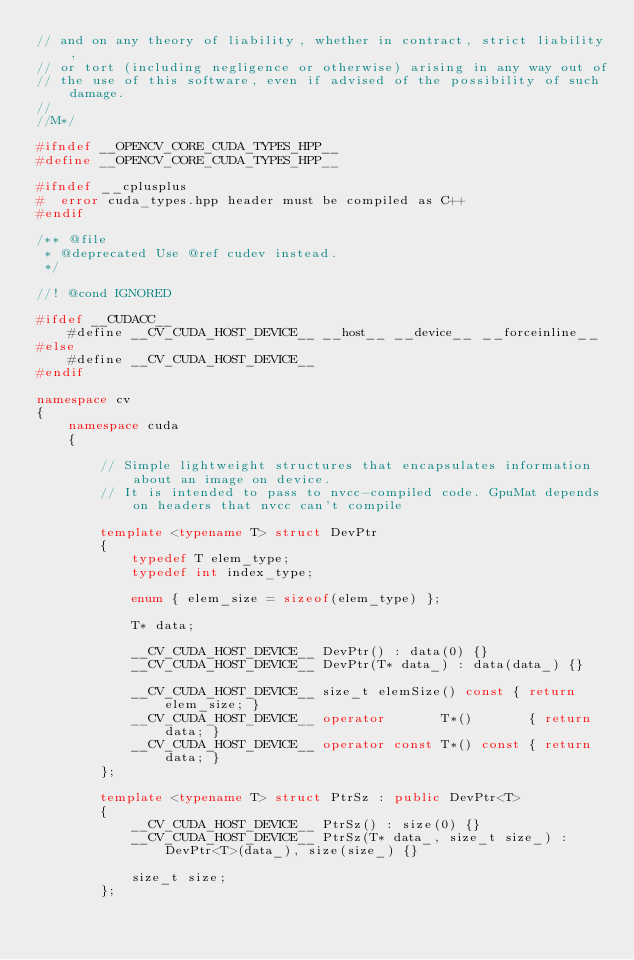Convert code to text. <code><loc_0><loc_0><loc_500><loc_500><_C++_>// and on any theory of liability, whether in contract, strict liability,
// or tort (including negligence or otherwise) arising in any way out of
// the use of this software, even if advised of the possibility of such damage.
//
//M*/

#ifndef __OPENCV_CORE_CUDA_TYPES_HPP__
#define __OPENCV_CORE_CUDA_TYPES_HPP__

#ifndef __cplusplus
#  error cuda_types.hpp header must be compiled as C++
#endif

/** @file
 * @deprecated Use @ref cudev instead.
 */

//! @cond IGNORED

#ifdef __CUDACC__
    #define __CV_CUDA_HOST_DEVICE__ __host__ __device__ __forceinline__
#else
    #define __CV_CUDA_HOST_DEVICE__
#endif

namespace cv
{
    namespace cuda
    {

        // Simple lightweight structures that encapsulates information about an image on device.
        // It is intended to pass to nvcc-compiled code. GpuMat depends on headers that nvcc can't compile

        template <typename T> struct DevPtr
        {
            typedef T elem_type;
            typedef int index_type;

            enum { elem_size = sizeof(elem_type) };

            T* data;

            __CV_CUDA_HOST_DEVICE__ DevPtr() : data(0) {}
            __CV_CUDA_HOST_DEVICE__ DevPtr(T* data_) : data(data_) {}

            __CV_CUDA_HOST_DEVICE__ size_t elemSize() const { return elem_size; }
            __CV_CUDA_HOST_DEVICE__ operator       T*()       { return data; }
            __CV_CUDA_HOST_DEVICE__ operator const T*() const { return data; }
        };

        template <typename T> struct PtrSz : public DevPtr<T>
        {
            __CV_CUDA_HOST_DEVICE__ PtrSz() : size(0) {}
            __CV_CUDA_HOST_DEVICE__ PtrSz(T* data_, size_t size_) : DevPtr<T>(data_), size(size_) {}

            size_t size;
        };
</code> 